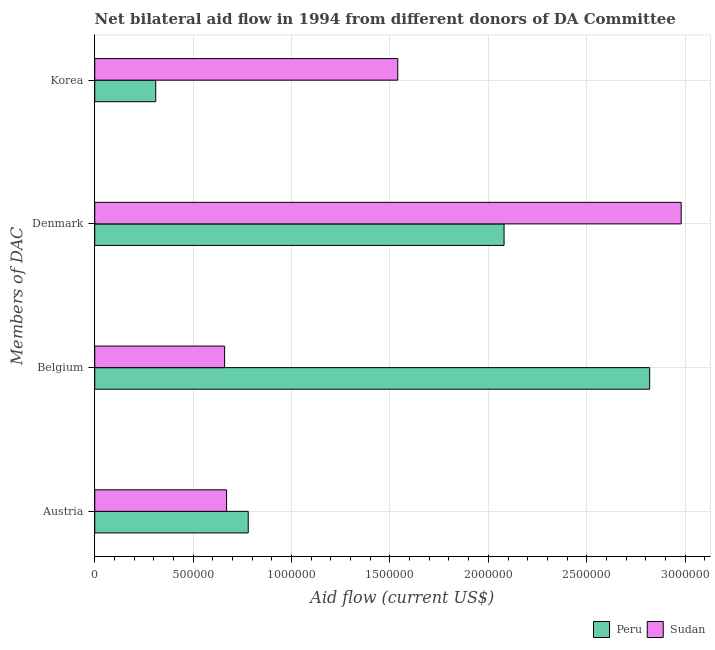How many different coloured bars are there?
Provide a succinct answer. 2. How many groups of bars are there?
Offer a very short reply. 4. Are the number of bars per tick equal to the number of legend labels?
Offer a terse response. Yes. How many bars are there on the 1st tick from the top?
Your answer should be very brief. 2. What is the amount of aid given by austria in Peru?
Ensure brevity in your answer.  7.80e+05. Across all countries, what is the maximum amount of aid given by belgium?
Offer a terse response. 2.82e+06. Across all countries, what is the minimum amount of aid given by belgium?
Ensure brevity in your answer.  6.60e+05. In which country was the amount of aid given by denmark maximum?
Offer a very short reply. Sudan. What is the total amount of aid given by austria in the graph?
Your answer should be very brief. 1.45e+06. What is the difference between the amount of aid given by korea in Peru and that in Sudan?
Ensure brevity in your answer.  -1.23e+06. What is the difference between the amount of aid given by belgium in Sudan and the amount of aid given by austria in Peru?
Provide a short and direct response. -1.20e+05. What is the average amount of aid given by denmark per country?
Your answer should be very brief. 2.53e+06. What is the difference between the amount of aid given by korea and amount of aid given by denmark in Peru?
Ensure brevity in your answer.  -1.77e+06. In how many countries, is the amount of aid given by belgium greater than 900000 US$?
Your answer should be compact. 1. What is the ratio of the amount of aid given by denmark in Peru to that in Sudan?
Offer a terse response. 0.7. What is the difference between the highest and the second highest amount of aid given by denmark?
Give a very brief answer. 9.00e+05. What is the difference between the highest and the lowest amount of aid given by belgium?
Offer a very short reply. 2.16e+06. Is the sum of the amount of aid given by korea in Peru and Sudan greater than the maximum amount of aid given by austria across all countries?
Give a very brief answer. Yes. Is it the case that in every country, the sum of the amount of aid given by austria and amount of aid given by korea is greater than the sum of amount of aid given by belgium and amount of aid given by denmark?
Ensure brevity in your answer.  No. Is it the case that in every country, the sum of the amount of aid given by austria and amount of aid given by belgium is greater than the amount of aid given by denmark?
Offer a terse response. No. How many bars are there?
Keep it short and to the point. 8. How many countries are there in the graph?
Keep it short and to the point. 2. What is the difference between two consecutive major ticks on the X-axis?
Give a very brief answer. 5.00e+05. Are the values on the major ticks of X-axis written in scientific E-notation?
Provide a succinct answer. No. Does the graph contain grids?
Provide a short and direct response. Yes. Where does the legend appear in the graph?
Your answer should be compact. Bottom right. How many legend labels are there?
Your answer should be very brief. 2. How are the legend labels stacked?
Offer a very short reply. Horizontal. What is the title of the graph?
Your response must be concise. Net bilateral aid flow in 1994 from different donors of DA Committee. What is the label or title of the Y-axis?
Offer a terse response. Members of DAC. What is the Aid flow (current US$) of Peru in Austria?
Offer a terse response. 7.80e+05. What is the Aid flow (current US$) of Sudan in Austria?
Ensure brevity in your answer.  6.70e+05. What is the Aid flow (current US$) in Peru in Belgium?
Provide a succinct answer. 2.82e+06. What is the Aid flow (current US$) in Sudan in Belgium?
Your answer should be compact. 6.60e+05. What is the Aid flow (current US$) in Peru in Denmark?
Give a very brief answer. 2.08e+06. What is the Aid flow (current US$) in Sudan in Denmark?
Offer a terse response. 2.98e+06. What is the Aid flow (current US$) of Sudan in Korea?
Provide a succinct answer. 1.54e+06. Across all Members of DAC, what is the maximum Aid flow (current US$) in Peru?
Your answer should be very brief. 2.82e+06. Across all Members of DAC, what is the maximum Aid flow (current US$) in Sudan?
Keep it short and to the point. 2.98e+06. What is the total Aid flow (current US$) of Peru in the graph?
Give a very brief answer. 5.99e+06. What is the total Aid flow (current US$) in Sudan in the graph?
Make the answer very short. 5.85e+06. What is the difference between the Aid flow (current US$) of Peru in Austria and that in Belgium?
Your answer should be very brief. -2.04e+06. What is the difference between the Aid flow (current US$) in Peru in Austria and that in Denmark?
Offer a terse response. -1.30e+06. What is the difference between the Aid flow (current US$) of Sudan in Austria and that in Denmark?
Ensure brevity in your answer.  -2.31e+06. What is the difference between the Aid flow (current US$) in Peru in Austria and that in Korea?
Keep it short and to the point. 4.70e+05. What is the difference between the Aid flow (current US$) of Sudan in Austria and that in Korea?
Your answer should be compact. -8.70e+05. What is the difference between the Aid flow (current US$) in Peru in Belgium and that in Denmark?
Give a very brief answer. 7.40e+05. What is the difference between the Aid flow (current US$) in Sudan in Belgium and that in Denmark?
Offer a very short reply. -2.32e+06. What is the difference between the Aid flow (current US$) in Peru in Belgium and that in Korea?
Offer a very short reply. 2.51e+06. What is the difference between the Aid flow (current US$) of Sudan in Belgium and that in Korea?
Ensure brevity in your answer.  -8.80e+05. What is the difference between the Aid flow (current US$) of Peru in Denmark and that in Korea?
Provide a short and direct response. 1.77e+06. What is the difference between the Aid flow (current US$) of Sudan in Denmark and that in Korea?
Ensure brevity in your answer.  1.44e+06. What is the difference between the Aid flow (current US$) of Peru in Austria and the Aid flow (current US$) of Sudan in Denmark?
Offer a terse response. -2.20e+06. What is the difference between the Aid flow (current US$) in Peru in Austria and the Aid flow (current US$) in Sudan in Korea?
Offer a very short reply. -7.60e+05. What is the difference between the Aid flow (current US$) in Peru in Belgium and the Aid flow (current US$) in Sudan in Denmark?
Your answer should be very brief. -1.60e+05. What is the difference between the Aid flow (current US$) in Peru in Belgium and the Aid flow (current US$) in Sudan in Korea?
Provide a short and direct response. 1.28e+06. What is the difference between the Aid flow (current US$) of Peru in Denmark and the Aid flow (current US$) of Sudan in Korea?
Provide a short and direct response. 5.40e+05. What is the average Aid flow (current US$) of Peru per Members of DAC?
Your response must be concise. 1.50e+06. What is the average Aid flow (current US$) of Sudan per Members of DAC?
Your answer should be compact. 1.46e+06. What is the difference between the Aid flow (current US$) in Peru and Aid flow (current US$) in Sudan in Belgium?
Your answer should be very brief. 2.16e+06. What is the difference between the Aid flow (current US$) in Peru and Aid flow (current US$) in Sudan in Denmark?
Provide a short and direct response. -9.00e+05. What is the difference between the Aid flow (current US$) in Peru and Aid flow (current US$) in Sudan in Korea?
Offer a very short reply. -1.23e+06. What is the ratio of the Aid flow (current US$) in Peru in Austria to that in Belgium?
Ensure brevity in your answer.  0.28. What is the ratio of the Aid flow (current US$) in Sudan in Austria to that in Belgium?
Provide a short and direct response. 1.02. What is the ratio of the Aid flow (current US$) of Peru in Austria to that in Denmark?
Make the answer very short. 0.38. What is the ratio of the Aid flow (current US$) in Sudan in Austria to that in Denmark?
Make the answer very short. 0.22. What is the ratio of the Aid flow (current US$) of Peru in Austria to that in Korea?
Ensure brevity in your answer.  2.52. What is the ratio of the Aid flow (current US$) in Sudan in Austria to that in Korea?
Make the answer very short. 0.44. What is the ratio of the Aid flow (current US$) in Peru in Belgium to that in Denmark?
Your response must be concise. 1.36. What is the ratio of the Aid flow (current US$) in Sudan in Belgium to that in Denmark?
Your answer should be very brief. 0.22. What is the ratio of the Aid flow (current US$) in Peru in Belgium to that in Korea?
Give a very brief answer. 9.1. What is the ratio of the Aid flow (current US$) in Sudan in Belgium to that in Korea?
Offer a very short reply. 0.43. What is the ratio of the Aid flow (current US$) in Peru in Denmark to that in Korea?
Offer a very short reply. 6.71. What is the ratio of the Aid flow (current US$) in Sudan in Denmark to that in Korea?
Provide a short and direct response. 1.94. What is the difference between the highest and the second highest Aid flow (current US$) of Peru?
Keep it short and to the point. 7.40e+05. What is the difference between the highest and the second highest Aid flow (current US$) of Sudan?
Keep it short and to the point. 1.44e+06. What is the difference between the highest and the lowest Aid flow (current US$) of Peru?
Provide a short and direct response. 2.51e+06. What is the difference between the highest and the lowest Aid flow (current US$) of Sudan?
Your answer should be compact. 2.32e+06. 